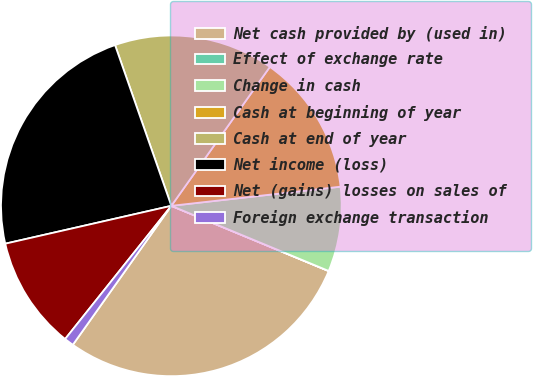Convert chart. <chart><loc_0><loc_0><loc_500><loc_500><pie_chart><fcel>Net cash provided by (used in)<fcel>Effect of exchange rate<fcel>Change in cash<fcel>Cash at beginning of year<fcel>Cash at end of year<fcel>Net income (loss)<fcel>Net (gains) losses on sales of<fcel>Foreign exchange transaction<nl><fcel>28.56%<fcel>0.01%<fcel>8.04%<fcel>13.39%<fcel>15.18%<fcel>23.21%<fcel>10.72%<fcel>0.9%<nl></chart> 